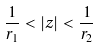Convert formula to latex. <formula><loc_0><loc_0><loc_500><loc_500>\frac { 1 } { r _ { 1 } } < | z | < \frac { 1 } { r _ { 2 } }</formula> 